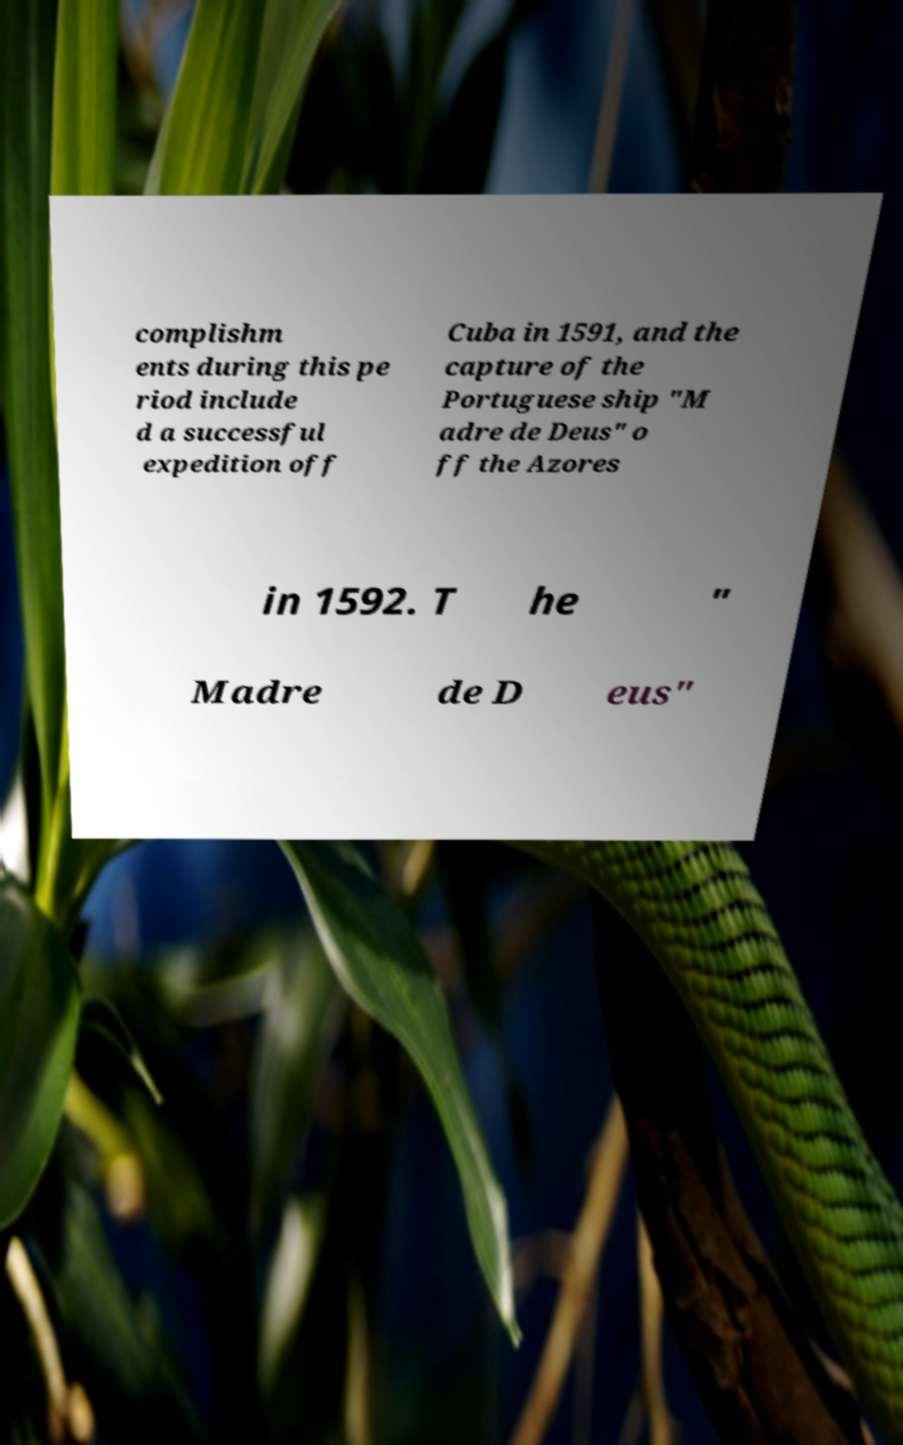Could you assist in decoding the text presented in this image and type it out clearly? complishm ents during this pe riod include d a successful expedition off Cuba in 1591, and the capture of the Portuguese ship "M adre de Deus" o ff the Azores in 1592. T he " Madre de D eus" 